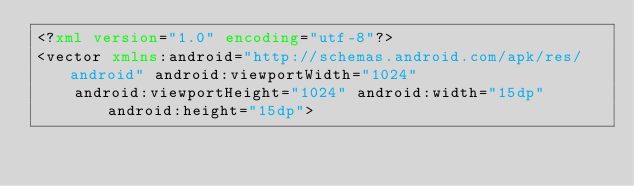<code> <loc_0><loc_0><loc_500><loc_500><_XML_><?xml version="1.0" encoding="utf-8"?>
<vector xmlns:android="http://schemas.android.com/apk/res/android" android:viewportWidth="1024"
    android:viewportHeight="1024" android:width="15dp" android:height="15dp"></code> 